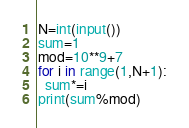Convert code to text. <code><loc_0><loc_0><loc_500><loc_500><_Python_>N=int(input())
sum=1
mod=10**9+7
for i in range(1,N+1):
  sum*=i
print(sum%mod)</code> 